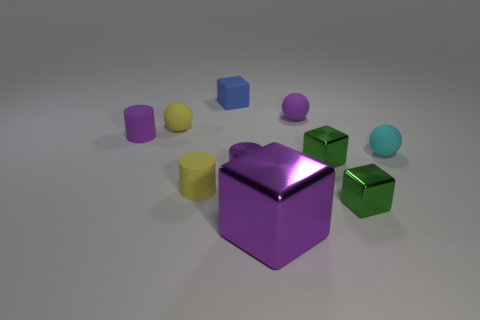Subtract all gray blocks. Subtract all yellow spheres. How many blocks are left? 4 Subtract all cubes. How many objects are left? 6 Add 2 cyan rubber things. How many cyan rubber things are left? 3 Add 9 big metallic cubes. How many big metallic cubes exist? 10 Subtract 1 yellow spheres. How many objects are left? 9 Subtract all tiny cyan matte balls. Subtract all tiny purple metallic things. How many objects are left? 8 